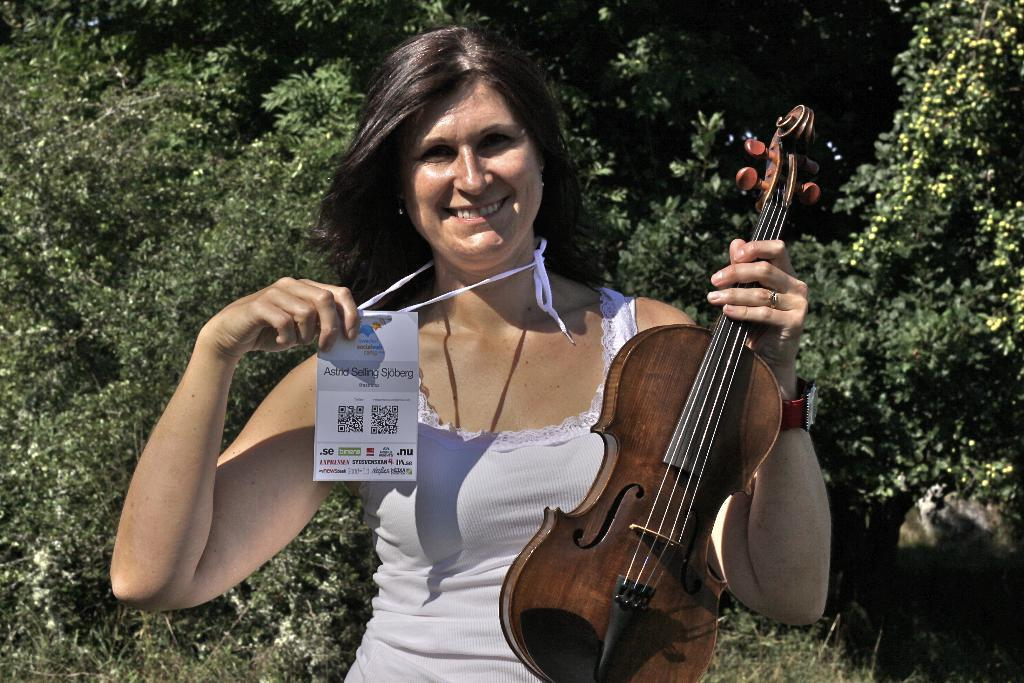Who is the main subject in the image? There is a woman in the image. What is the woman wearing? The woman is wearing a white dress. What is the woman holding in her hands? The woman is holding a violin in one hand and a card in the other hand. What can be seen in the background of the image? There are trees visible in the background of the image. What type of scent can be detected from the duck in the image? There is no duck present in the image, so it is not possible to detect any scent from a duck. 